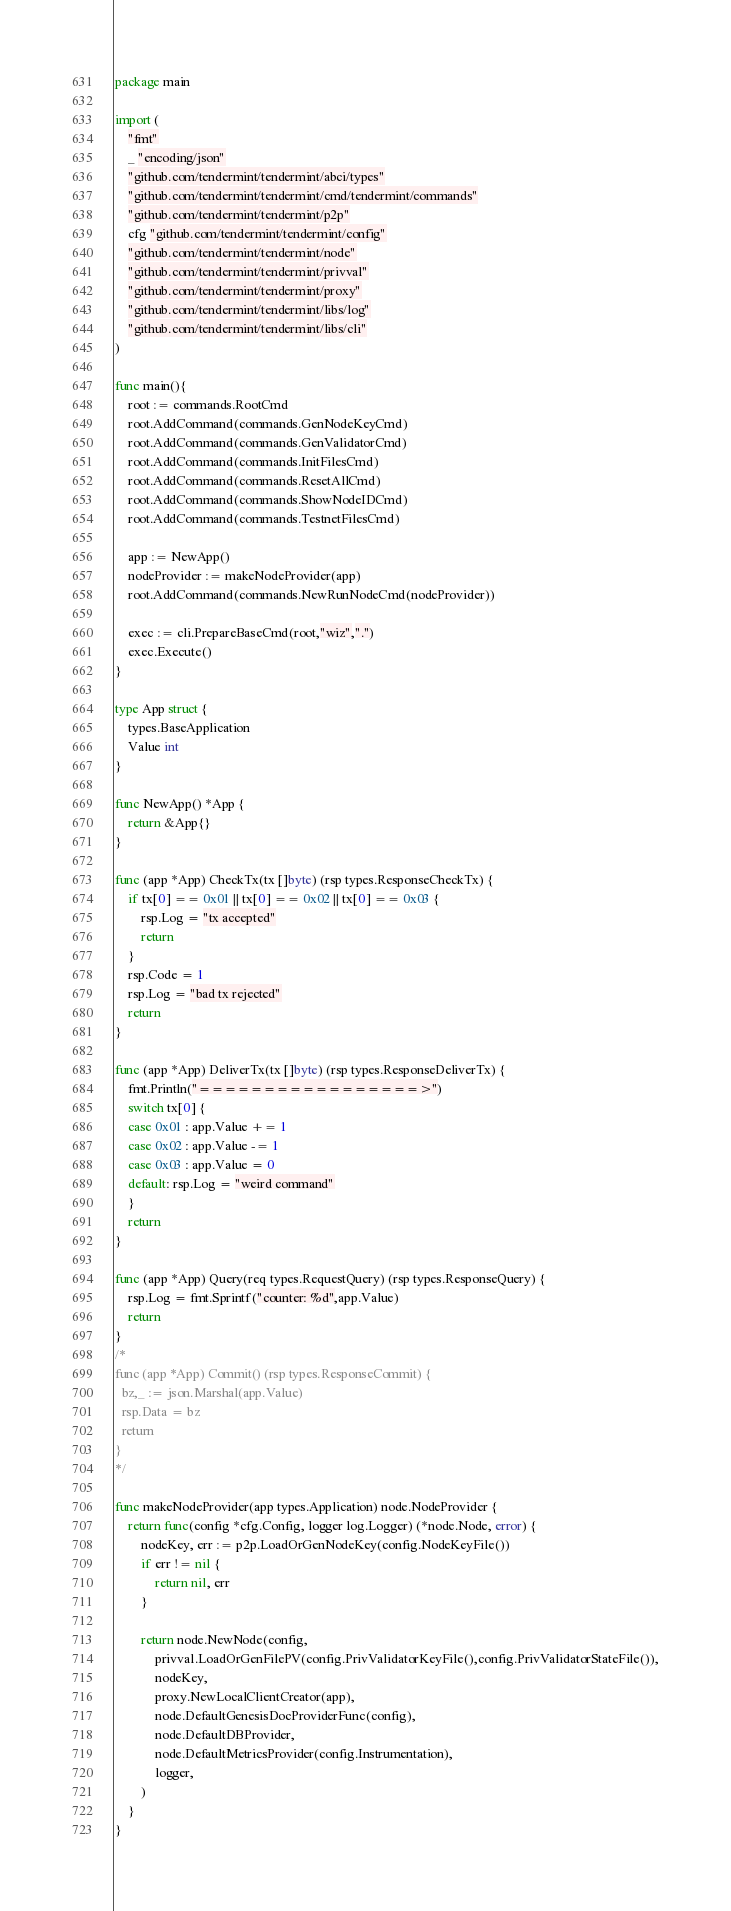Convert code to text. <code><loc_0><loc_0><loc_500><loc_500><_Go_>package main

import (
	"fmt"
	_ "encoding/json"
	"github.com/tendermint/tendermint/abci/types"
	"github.com/tendermint/tendermint/cmd/tendermint/commands"
	"github.com/tendermint/tendermint/p2p"
	cfg "github.com/tendermint/tendermint/config"
	"github.com/tendermint/tendermint/node"
	"github.com/tendermint/tendermint/privval"
	"github.com/tendermint/tendermint/proxy"
	"github.com/tendermint/tendermint/libs/log"
	"github.com/tendermint/tendermint/libs/cli"
)

func main(){
	root := commands.RootCmd
	root.AddCommand(commands.GenNodeKeyCmd)
	root.AddCommand(commands.GenValidatorCmd)
	root.AddCommand(commands.InitFilesCmd)
	root.AddCommand(commands.ResetAllCmd)
	root.AddCommand(commands.ShowNodeIDCmd)
	root.AddCommand(commands.TestnetFilesCmd)

	app := NewApp()
	nodeProvider := makeNodeProvider(app)
	root.AddCommand(commands.NewRunNodeCmd(nodeProvider))

	exec := cli.PrepareBaseCmd(root,"wiz",".")
	exec.Execute()
}

type App struct {
	types.BaseApplication
	Value int
}

func NewApp() *App {
	return &App{}
}

func (app *App) CheckTx(tx []byte) (rsp types.ResponseCheckTx) {
	if tx[0] == 0x01 || tx[0] == 0x02 || tx[0] == 0x03 {
		rsp.Log = "tx accepted"
		return
	}
	rsp.Code = 1
	rsp.Log = "bad tx rejected"
	return
}

func (app *App) DeliverTx(tx []byte) (rsp types.ResponseDeliverTx) {
	fmt.Println("=================>")
	switch tx[0] {
	case 0x01 : app.Value += 1
	case 0x02 : app.Value -= 1
	case 0x03 : app.Value = 0
	default: rsp.Log = "weird command"
	}
	return
}

func (app *App) Query(req types.RequestQuery) (rsp types.ResponseQuery) {
	rsp.Log = fmt.Sprintf("counter: %d",app.Value)
	return
}
/*
func (app *App) Commit() (rsp types.ResponseCommit) {
  bz,_ := json.Marshal(app.Value)
  rsp.Data = bz
  return
}
*/

func makeNodeProvider(app types.Application) node.NodeProvider {
	return func(config *cfg.Config, logger log.Logger) (*node.Node, error) {
		nodeKey, err := p2p.LoadOrGenNodeKey(config.NodeKeyFile())
		if err != nil {
			return nil, err
		}

		return node.NewNode(config,
			privval.LoadOrGenFilePV(config.PrivValidatorKeyFile(),config.PrivValidatorStateFile()),
			nodeKey,
			proxy.NewLocalClientCreator(app),
			node.DefaultGenesisDocProviderFunc(config),
			node.DefaultDBProvider,
			node.DefaultMetricsProvider(config.Instrumentation),
			logger,
		)
	}
}
</code> 